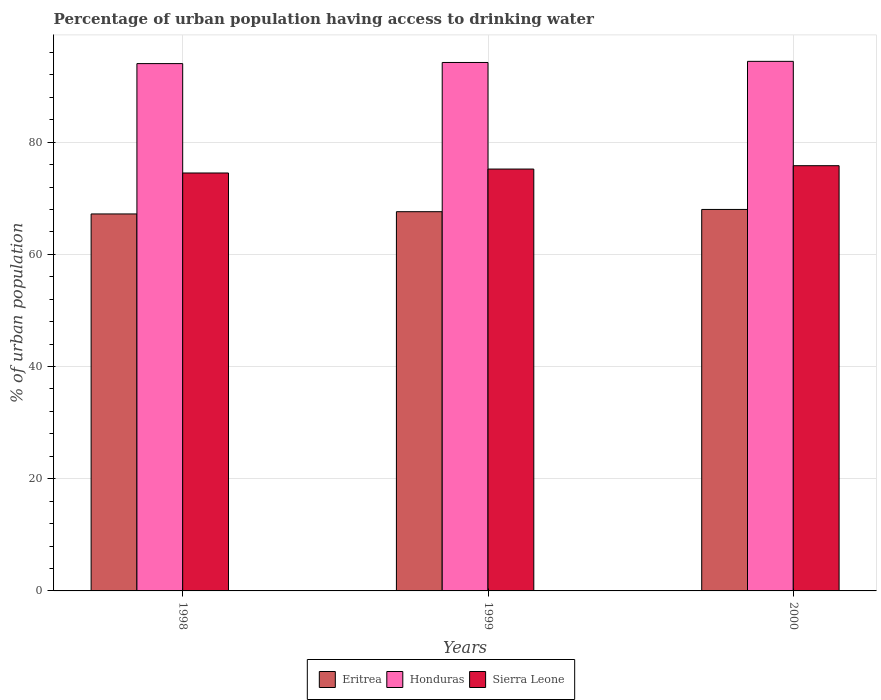How many different coloured bars are there?
Make the answer very short. 3. Are the number of bars per tick equal to the number of legend labels?
Your answer should be very brief. Yes. Are the number of bars on each tick of the X-axis equal?
Keep it short and to the point. Yes. How many bars are there on the 2nd tick from the left?
Give a very brief answer. 3. How many bars are there on the 1st tick from the right?
Your answer should be very brief. 3. What is the label of the 2nd group of bars from the left?
Make the answer very short. 1999. In how many cases, is the number of bars for a given year not equal to the number of legend labels?
Offer a very short reply. 0. Across all years, what is the maximum percentage of urban population having access to drinking water in Sierra Leone?
Provide a succinct answer. 75.8. Across all years, what is the minimum percentage of urban population having access to drinking water in Sierra Leone?
Keep it short and to the point. 74.5. In which year was the percentage of urban population having access to drinking water in Sierra Leone maximum?
Offer a terse response. 2000. What is the total percentage of urban population having access to drinking water in Honduras in the graph?
Make the answer very short. 282.6. What is the difference between the percentage of urban population having access to drinking water in Honduras in 1998 and that in 1999?
Offer a very short reply. -0.2. What is the difference between the percentage of urban population having access to drinking water in Sierra Leone in 1998 and the percentage of urban population having access to drinking water in Honduras in 1999?
Your answer should be very brief. -19.7. What is the average percentage of urban population having access to drinking water in Sierra Leone per year?
Provide a short and direct response. 75.17. In the year 1998, what is the difference between the percentage of urban population having access to drinking water in Honduras and percentage of urban population having access to drinking water in Eritrea?
Your answer should be compact. 26.8. What is the ratio of the percentage of urban population having access to drinking water in Sierra Leone in 1998 to that in 1999?
Provide a succinct answer. 0.99. Is the percentage of urban population having access to drinking water in Eritrea in 1998 less than that in 2000?
Your answer should be very brief. Yes. Is the difference between the percentage of urban population having access to drinking water in Honduras in 1998 and 2000 greater than the difference between the percentage of urban population having access to drinking water in Eritrea in 1998 and 2000?
Your answer should be very brief. Yes. What is the difference between the highest and the second highest percentage of urban population having access to drinking water in Sierra Leone?
Make the answer very short. 0.6. What is the difference between the highest and the lowest percentage of urban population having access to drinking water in Sierra Leone?
Offer a terse response. 1.3. Is the sum of the percentage of urban population having access to drinking water in Sierra Leone in 1998 and 1999 greater than the maximum percentage of urban population having access to drinking water in Eritrea across all years?
Provide a succinct answer. Yes. What does the 1st bar from the left in 1998 represents?
Your response must be concise. Eritrea. What does the 2nd bar from the right in 1998 represents?
Make the answer very short. Honduras. How many bars are there?
Your answer should be compact. 9. How many years are there in the graph?
Offer a terse response. 3. Does the graph contain grids?
Make the answer very short. Yes. Where does the legend appear in the graph?
Make the answer very short. Bottom center. How many legend labels are there?
Offer a terse response. 3. What is the title of the graph?
Provide a short and direct response. Percentage of urban population having access to drinking water. What is the label or title of the X-axis?
Give a very brief answer. Years. What is the label or title of the Y-axis?
Give a very brief answer. % of urban population. What is the % of urban population in Eritrea in 1998?
Give a very brief answer. 67.2. What is the % of urban population of Honduras in 1998?
Your answer should be compact. 94. What is the % of urban population in Sierra Leone in 1998?
Offer a very short reply. 74.5. What is the % of urban population of Eritrea in 1999?
Provide a short and direct response. 67.6. What is the % of urban population in Honduras in 1999?
Ensure brevity in your answer.  94.2. What is the % of urban population of Sierra Leone in 1999?
Keep it short and to the point. 75.2. What is the % of urban population of Honduras in 2000?
Provide a succinct answer. 94.4. What is the % of urban population in Sierra Leone in 2000?
Your answer should be compact. 75.8. Across all years, what is the maximum % of urban population in Honduras?
Offer a very short reply. 94.4. Across all years, what is the maximum % of urban population of Sierra Leone?
Provide a short and direct response. 75.8. Across all years, what is the minimum % of urban population in Eritrea?
Your response must be concise. 67.2. Across all years, what is the minimum % of urban population of Honduras?
Ensure brevity in your answer.  94. Across all years, what is the minimum % of urban population of Sierra Leone?
Keep it short and to the point. 74.5. What is the total % of urban population in Eritrea in the graph?
Make the answer very short. 202.8. What is the total % of urban population in Honduras in the graph?
Your answer should be very brief. 282.6. What is the total % of urban population in Sierra Leone in the graph?
Your answer should be compact. 225.5. What is the difference between the % of urban population in Eritrea in 1998 and that in 1999?
Make the answer very short. -0.4. What is the difference between the % of urban population in Sierra Leone in 1998 and that in 1999?
Keep it short and to the point. -0.7. What is the difference between the % of urban population of Eritrea in 1998 and that in 2000?
Offer a terse response. -0.8. What is the difference between the % of urban population of Honduras in 1998 and that in 2000?
Provide a succinct answer. -0.4. What is the difference between the % of urban population in Sierra Leone in 1998 and that in 2000?
Provide a succinct answer. -1.3. What is the difference between the % of urban population in Eritrea in 1998 and the % of urban population in Honduras in 2000?
Ensure brevity in your answer.  -27.2. What is the difference between the % of urban population in Eritrea in 1999 and the % of urban population in Honduras in 2000?
Make the answer very short. -26.8. What is the average % of urban population of Eritrea per year?
Provide a short and direct response. 67.6. What is the average % of urban population in Honduras per year?
Offer a terse response. 94.2. What is the average % of urban population of Sierra Leone per year?
Your response must be concise. 75.17. In the year 1998, what is the difference between the % of urban population in Eritrea and % of urban population in Honduras?
Offer a terse response. -26.8. In the year 1999, what is the difference between the % of urban population in Eritrea and % of urban population in Honduras?
Your answer should be compact. -26.6. In the year 1999, what is the difference between the % of urban population in Eritrea and % of urban population in Sierra Leone?
Provide a succinct answer. -7.6. In the year 2000, what is the difference between the % of urban population of Eritrea and % of urban population of Honduras?
Ensure brevity in your answer.  -26.4. In the year 2000, what is the difference between the % of urban population in Eritrea and % of urban population in Sierra Leone?
Your answer should be compact. -7.8. In the year 2000, what is the difference between the % of urban population in Honduras and % of urban population in Sierra Leone?
Your answer should be compact. 18.6. What is the ratio of the % of urban population of Eritrea in 1998 to that in 1999?
Give a very brief answer. 0.99. What is the ratio of the % of urban population in Sierra Leone in 1998 to that in 1999?
Your answer should be very brief. 0.99. What is the ratio of the % of urban population of Sierra Leone in 1998 to that in 2000?
Provide a short and direct response. 0.98. What is the ratio of the % of urban population of Sierra Leone in 1999 to that in 2000?
Provide a short and direct response. 0.99. What is the difference between the highest and the second highest % of urban population in Honduras?
Offer a terse response. 0.2. What is the difference between the highest and the lowest % of urban population of Eritrea?
Offer a very short reply. 0.8. What is the difference between the highest and the lowest % of urban population of Honduras?
Ensure brevity in your answer.  0.4. What is the difference between the highest and the lowest % of urban population of Sierra Leone?
Your response must be concise. 1.3. 